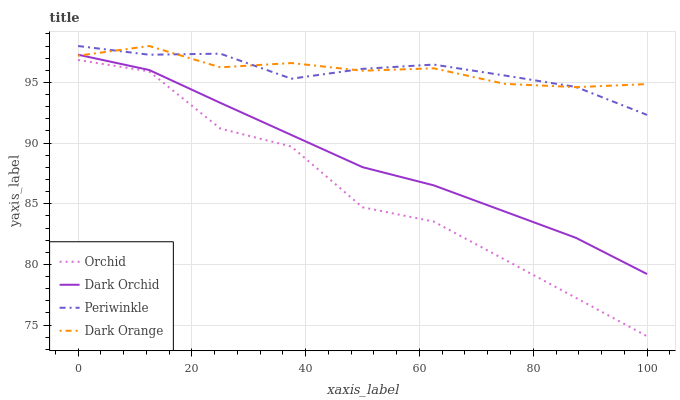Does Orchid have the minimum area under the curve?
Answer yes or no. Yes. Does Dark Orange have the maximum area under the curve?
Answer yes or no. Yes. Does Periwinkle have the minimum area under the curve?
Answer yes or no. No. Does Periwinkle have the maximum area under the curve?
Answer yes or no. No. Is Dark Orchid the smoothest?
Answer yes or no. Yes. Is Orchid the roughest?
Answer yes or no. Yes. Is Periwinkle the smoothest?
Answer yes or no. No. Is Periwinkle the roughest?
Answer yes or no. No. Does Orchid have the lowest value?
Answer yes or no. Yes. Does Periwinkle have the lowest value?
Answer yes or no. No. Does Periwinkle have the highest value?
Answer yes or no. Yes. Does Dark Orchid have the highest value?
Answer yes or no. No. Is Dark Orchid less than Periwinkle?
Answer yes or no. Yes. Is Dark Orange greater than Orchid?
Answer yes or no. Yes. Does Dark Orange intersect Dark Orchid?
Answer yes or no. Yes. Is Dark Orange less than Dark Orchid?
Answer yes or no. No. Is Dark Orange greater than Dark Orchid?
Answer yes or no. No. Does Dark Orchid intersect Periwinkle?
Answer yes or no. No. 